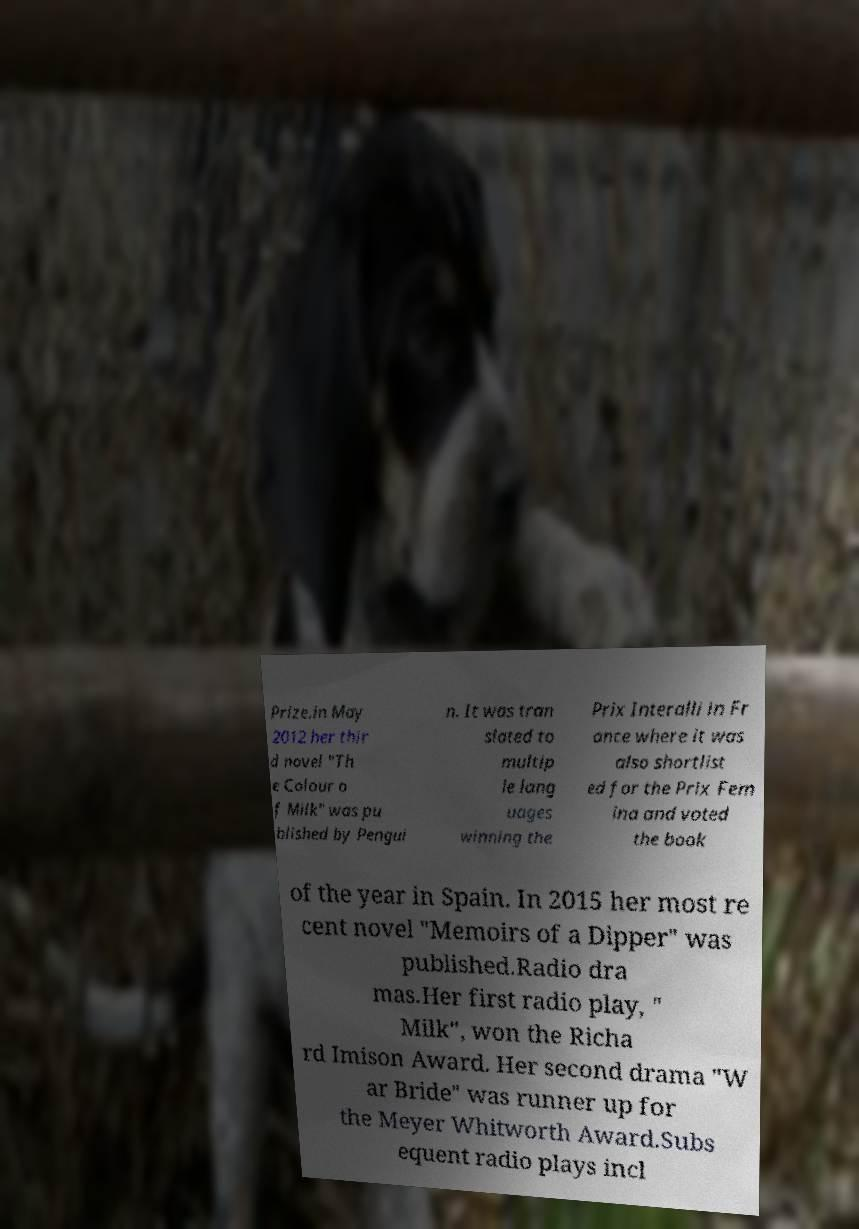I need the written content from this picture converted into text. Can you do that? Prize.in May 2012 her thir d novel "Th e Colour o f Milk" was pu blished by Pengui n. It was tran slated to multip le lang uages winning the Prix Interalli in Fr ance where it was also shortlist ed for the Prix Fem ina and voted the book of the year in Spain. In 2015 her most re cent novel "Memoirs of a Dipper" was published.Radio dra mas.Her first radio play, " Milk", won the Richa rd Imison Award. Her second drama "W ar Bride" was runner up for the Meyer Whitworth Award.Subs equent radio plays incl 